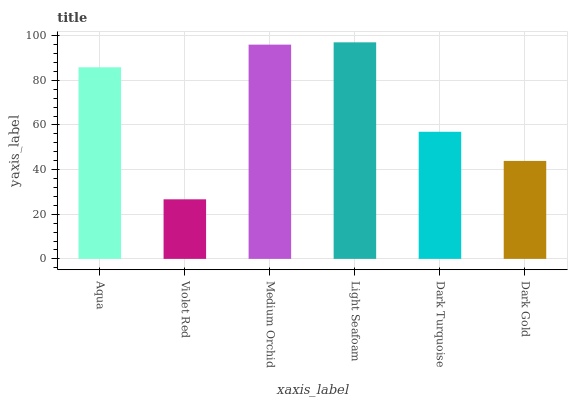Is Violet Red the minimum?
Answer yes or no. Yes. Is Light Seafoam the maximum?
Answer yes or no. Yes. Is Medium Orchid the minimum?
Answer yes or no. No. Is Medium Orchid the maximum?
Answer yes or no. No. Is Medium Orchid greater than Violet Red?
Answer yes or no. Yes. Is Violet Red less than Medium Orchid?
Answer yes or no. Yes. Is Violet Red greater than Medium Orchid?
Answer yes or no. No. Is Medium Orchid less than Violet Red?
Answer yes or no. No. Is Aqua the high median?
Answer yes or no. Yes. Is Dark Turquoise the low median?
Answer yes or no. Yes. Is Dark Gold the high median?
Answer yes or no. No. Is Aqua the low median?
Answer yes or no. No. 